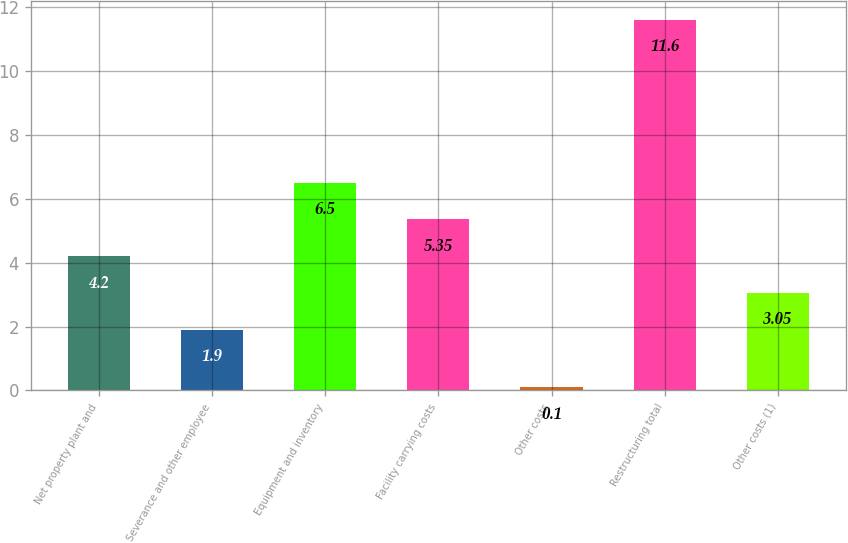Convert chart. <chart><loc_0><loc_0><loc_500><loc_500><bar_chart><fcel>Net property plant and<fcel>Severance and other employee<fcel>Equipment and inventory<fcel>Facility carrying costs<fcel>Other costs<fcel>Restructuring total<fcel>Other costs (1)<nl><fcel>4.2<fcel>1.9<fcel>6.5<fcel>5.35<fcel>0.1<fcel>11.6<fcel>3.05<nl></chart> 